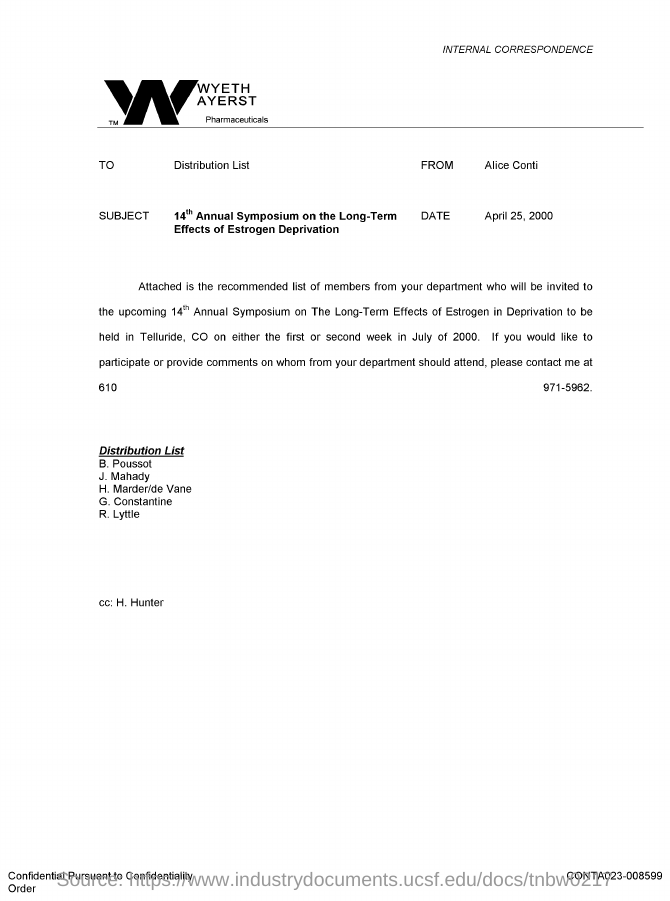Who is the sender of this document?
Your response must be concise. Alice conti. To whom, the document is addressed?
Make the answer very short. Distribution List. What is the issued date of this document?
Your response must be concise. APRIL 25, 2000. Which Company's Internal Correspondence is this?
Make the answer very short. WYETH AYERST Pharmaceuticals. 